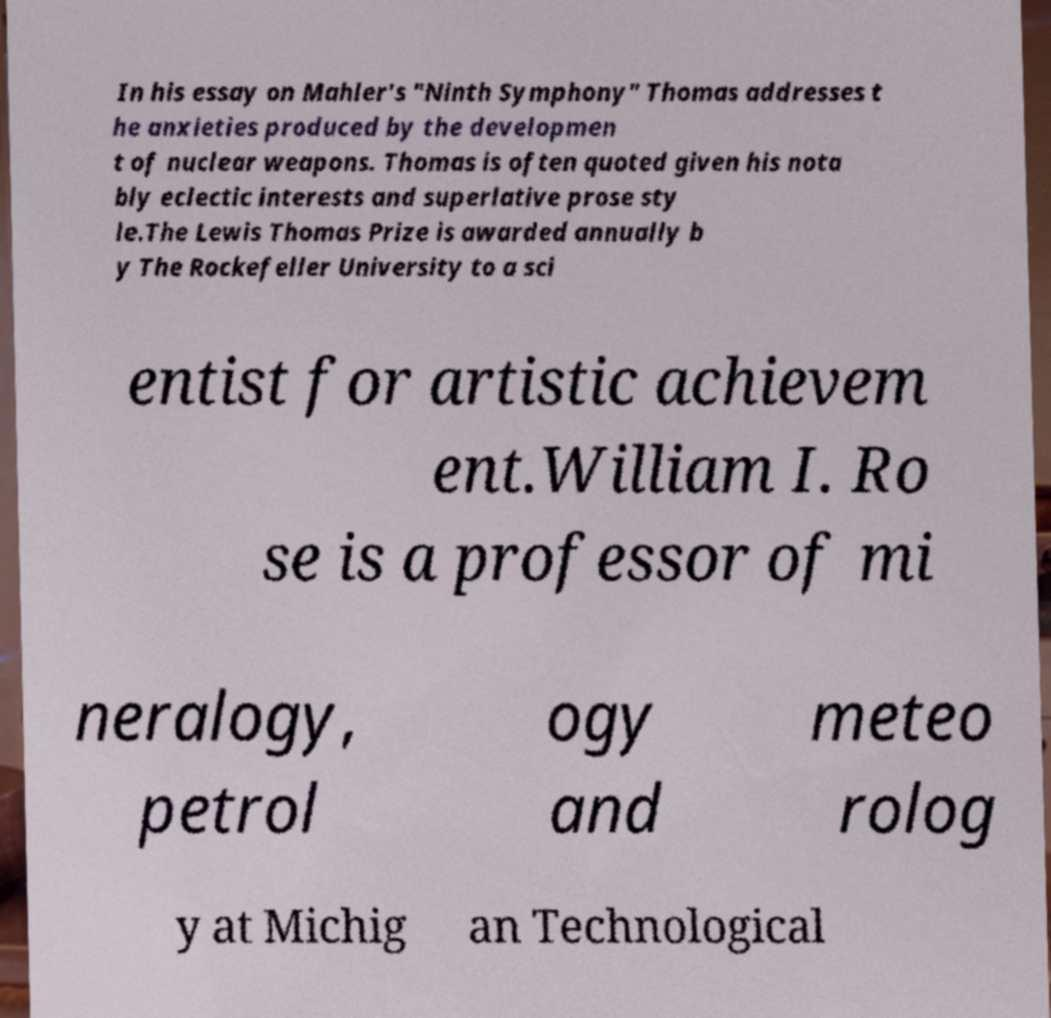There's text embedded in this image that I need extracted. Can you transcribe it verbatim? In his essay on Mahler's "Ninth Symphony" Thomas addresses t he anxieties produced by the developmen t of nuclear weapons. Thomas is often quoted given his nota bly eclectic interests and superlative prose sty le.The Lewis Thomas Prize is awarded annually b y The Rockefeller University to a sci entist for artistic achievem ent.William I. Ro se is a professor of mi neralogy, petrol ogy and meteo rolog y at Michig an Technological 